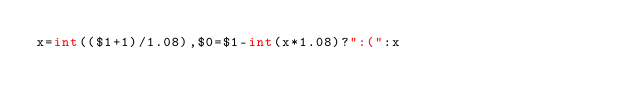<code> <loc_0><loc_0><loc_500><loc_500><_Awk_>x=int(($1+1)/1.08),$0=$1-int(x*1.08)?":(":x</code> 